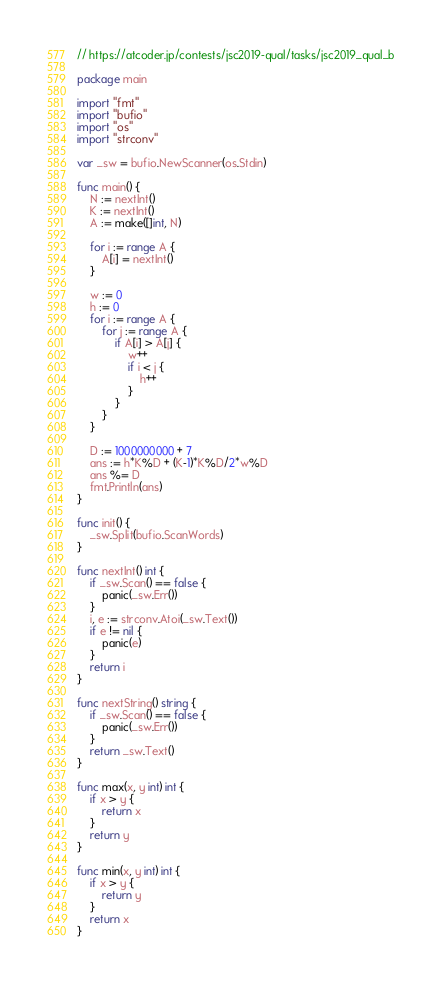Convert code to text. <code><loc_0><loc_0><loc_500><loc_500><_Go_>// https://atcoder.jp/contests/jsc2019-qual/tasks/jsc2019_qual_b

package main

import "fmt"
import "bufio"
import "os"
import "strconv"

var _sw = bufio.NewScanner(os.Stdin)

func main() {
	N := nextInt()
	K := nextInt()
	A := make([]int, N)

	for i := range A {
		A[i] = nextInt()
	}

	w := 0
	h := 0
	for i := range A {
		for j := range A {
			if A[i] > A[j] {
				w++
				if i < j {
					h++
				}
			}
		}
	}

	D := 1000000000 + 7
	ans := h*K%D + (K-1)*K%D/2*w%D
	ans %= D
	fmt.Println(ans)
}

func init() {
	_sw.Split(bufio.ScanWords)
}

func nextInt() int {
	if _sw.Scan() == false {
		panic(_sw.Err())
	}
	i, e := strconv.Atoi(_sw.Text())
	if e != nil {
		panic(e)
	}
	return i
}

func nextString() string {
	if _sw.Scan() == false {
		panic(_sw.Err())
	}
	return _sw.Text()
}

func max(x, y int) int {
	if x > y {
		return x
	}
	return y
}

func min(x, y int) int {
	if x > y {
		return y
	}
	return x
}
</code> 